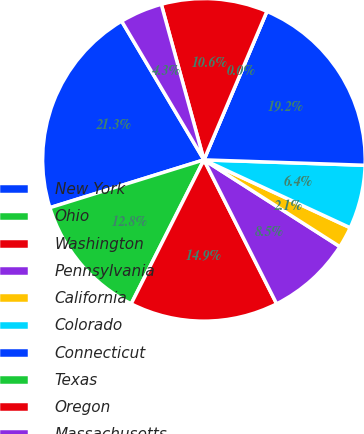Convert chart to OTSL. <chart><loc_0><loc_0><loc_500><loc_500><pie_chart><fcel>New York<fcel>Ohio<fcel>Washington<fcel>Pennsylvania<fcel>California<fcel>Colorado<fcel>Connecticut<fcel>Texas<fcel>Oregon<fcel>Massachusetts<nl><fcel>21.27%<fcel>12.76%<fcel>14.89%<fcel>8.51%<fcel>2.13%<fcel>6.38%<fcel>19.15%<fcel>0.0%<fcel>10.64%<fcel>4.26%<nl></chart> 